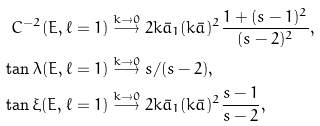<formula> <loc_0><loc_0><loc_500><loc_500>C ^ { - 2 } ( E , \ell = 1 ) & \stackrel { k \rightarrow 0 } { \longrightarrow } 2 k \bar { a } _ { 1 } ( k \bar { a } ) ^ { 2 } \frac { 1 + ( s - 1 ) ^ { 2 } } { ( s - 2 ) ^ { 2 } } , \\ \tan \lambda ( E , \ell = 1 ) & \stackrel { k \rightarrow 0 } { \longrightarrow } s / ( s - 2 ) , \\ \tan \xi ( E , \ell = 1 ) & \stackrel { k \rightarrow 0 } { \longrightarrow } 2 k \bar { a } _ { 1 } ( k \bar { a } ) ^ { 2 } \frac { s - 1 } { s - 2 } ,</formula> 